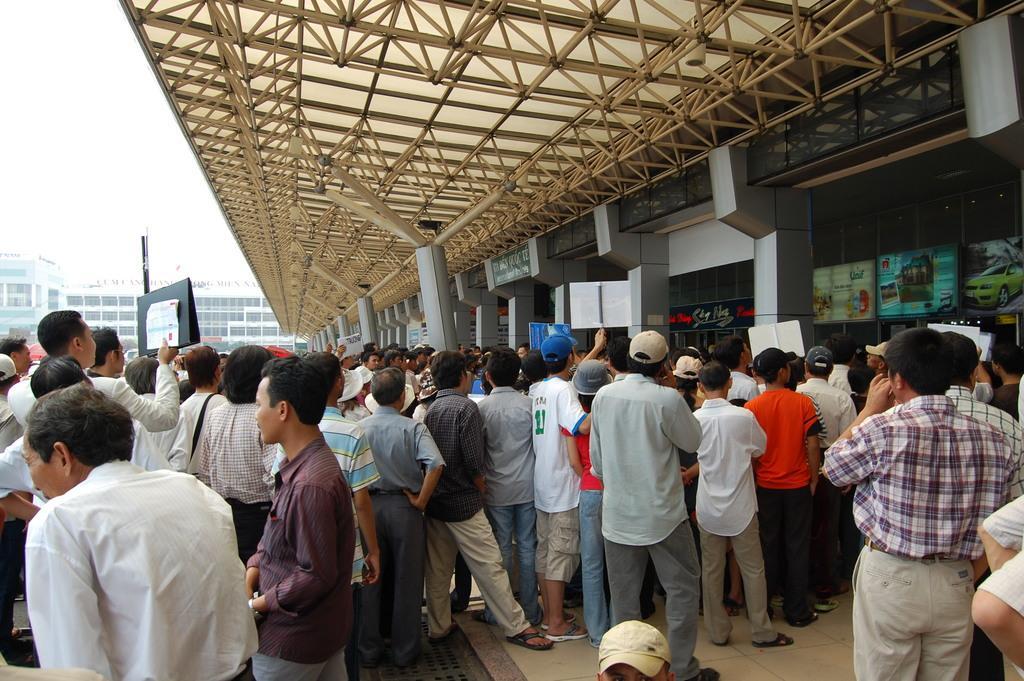Please provide a concise description of this image. In this image I can see in the middle a group of people are standing, on the right side there is a building. 